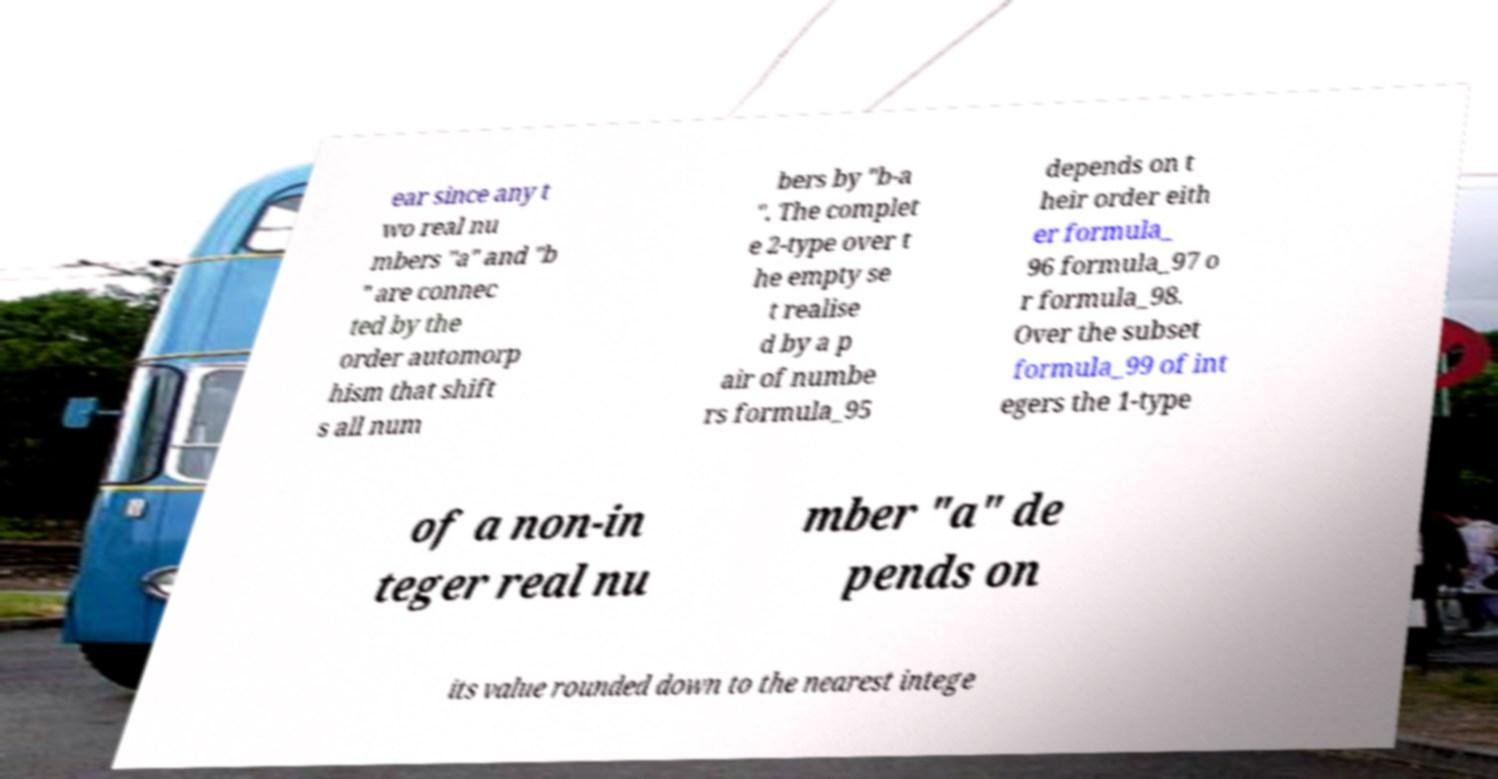There's text embedded in this image that I need extracted. Can you transcribe it verbatim? ear since any t wo real nu mbers "a" and "b " are connec ted by the order automorp hism that shift s all num bers by "b-a ". The complet e 2-type over t he empty se t realise d by a p air of numbe rs formula_95 depends on t heir order eith er formula_ 96 formula_97 o r formula_98. Over the subset formula_99 of int egers the 1-type of a non-in teger real nu mber "a" de pends on its value rounded down to the nearest intege 